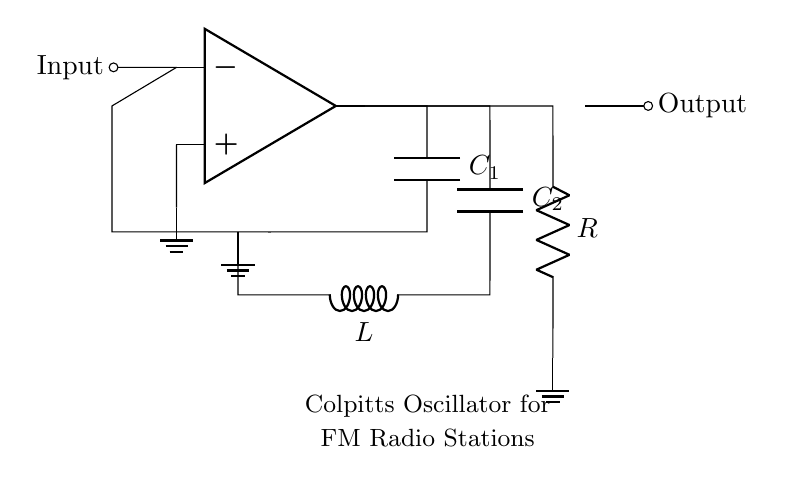What components are used in the circuit? The components in the circuit include an operational amplifier, two capacitors (C1 and C2), one inductor (L), and one resistor (R).
Answer: Operational amplifier, capacitors, inductor, resistor What is the role of the inductor in this oscillator circuit? The inductor functions as part of the resonant circuit, which helps determine the frequency of oscillation in conjunction with the capacitors.
Answer: Resonant circuit component How many capacitors are present in the oscillator? There are two capacitors shown in the circuit diagram.
Answer: Two capacitors What type of oscillator is represented by this circuit? This circuit diagram represents a Colpitts oscillator which is commonly used in frequency modulation applications.
Answer: Colpitts oscillator What does the output represent in the context of the circuit? The output node indicates where the oscillating signal can be accessed for further processing, often utilized in FM radio stations.
Answer: Access point for oscillating signal How does the addition of capacitors C1 and C2 affect the frequency of oscillation? The capacitors together with the inductor form a tank circuit, where the values of C1 and C2 determine the resonant frequency based on the formula for the frequency of a Colpitts oscillator.
Answer: Determines resonant frequency What is the significance of grounding the non-inverting input of the op-amp? Grounding the non-inverting input sets a reference voltage for the op-amp, enabling it to amplify the signal created by the oscillating circuit.
Answer: Reference voltage setup 